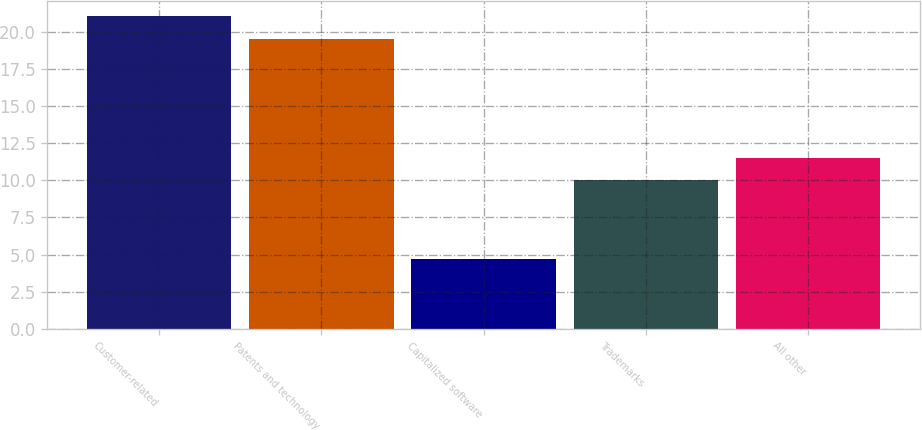Convert chart. <chart><loc_0><loc_0><loc_500><loc_500><bar_chart><fcel>Customer-related<fcel>Patents and technology<fcel>Capitalized software<fcel>Trademarks<fcel>All other<nl><fcel>21.03<fcel>19.5<fcel>4.7<fcel>10<fcel>11.53<nl></chart> 